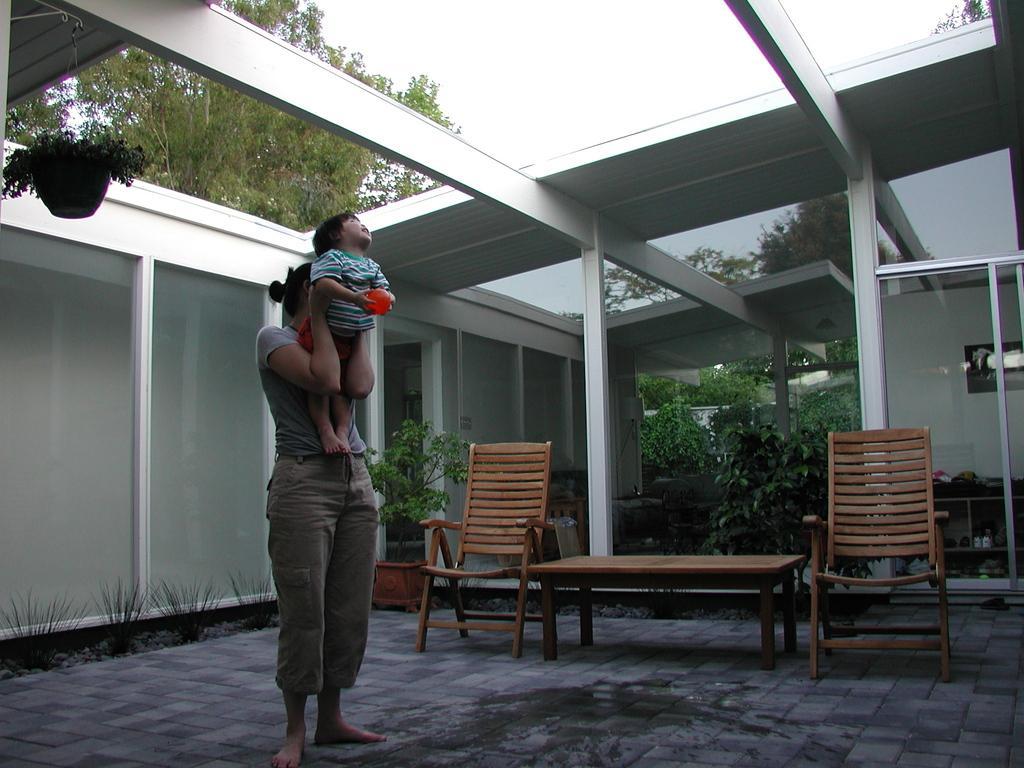Could you give a brief overview of what you see in this image? In this picture there is a woman who is wearing a grey top and is holding a baby. Baby is holding a ball in his hand. There is a flower pot at the corner. There is some grass on the ground. There is a chair and a table. There are some plants at the background. There is a shoe rack on to the right side. There is a tree at the background. 